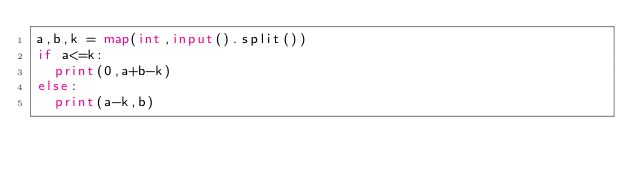<code> <loc_0><loc_0><loc_500><loc_500><_Python_>a,b,k = map(int,input().split())
if a<=k:
  print(0,a+b-k)
else:
  print(a-k,b)
  </code> 